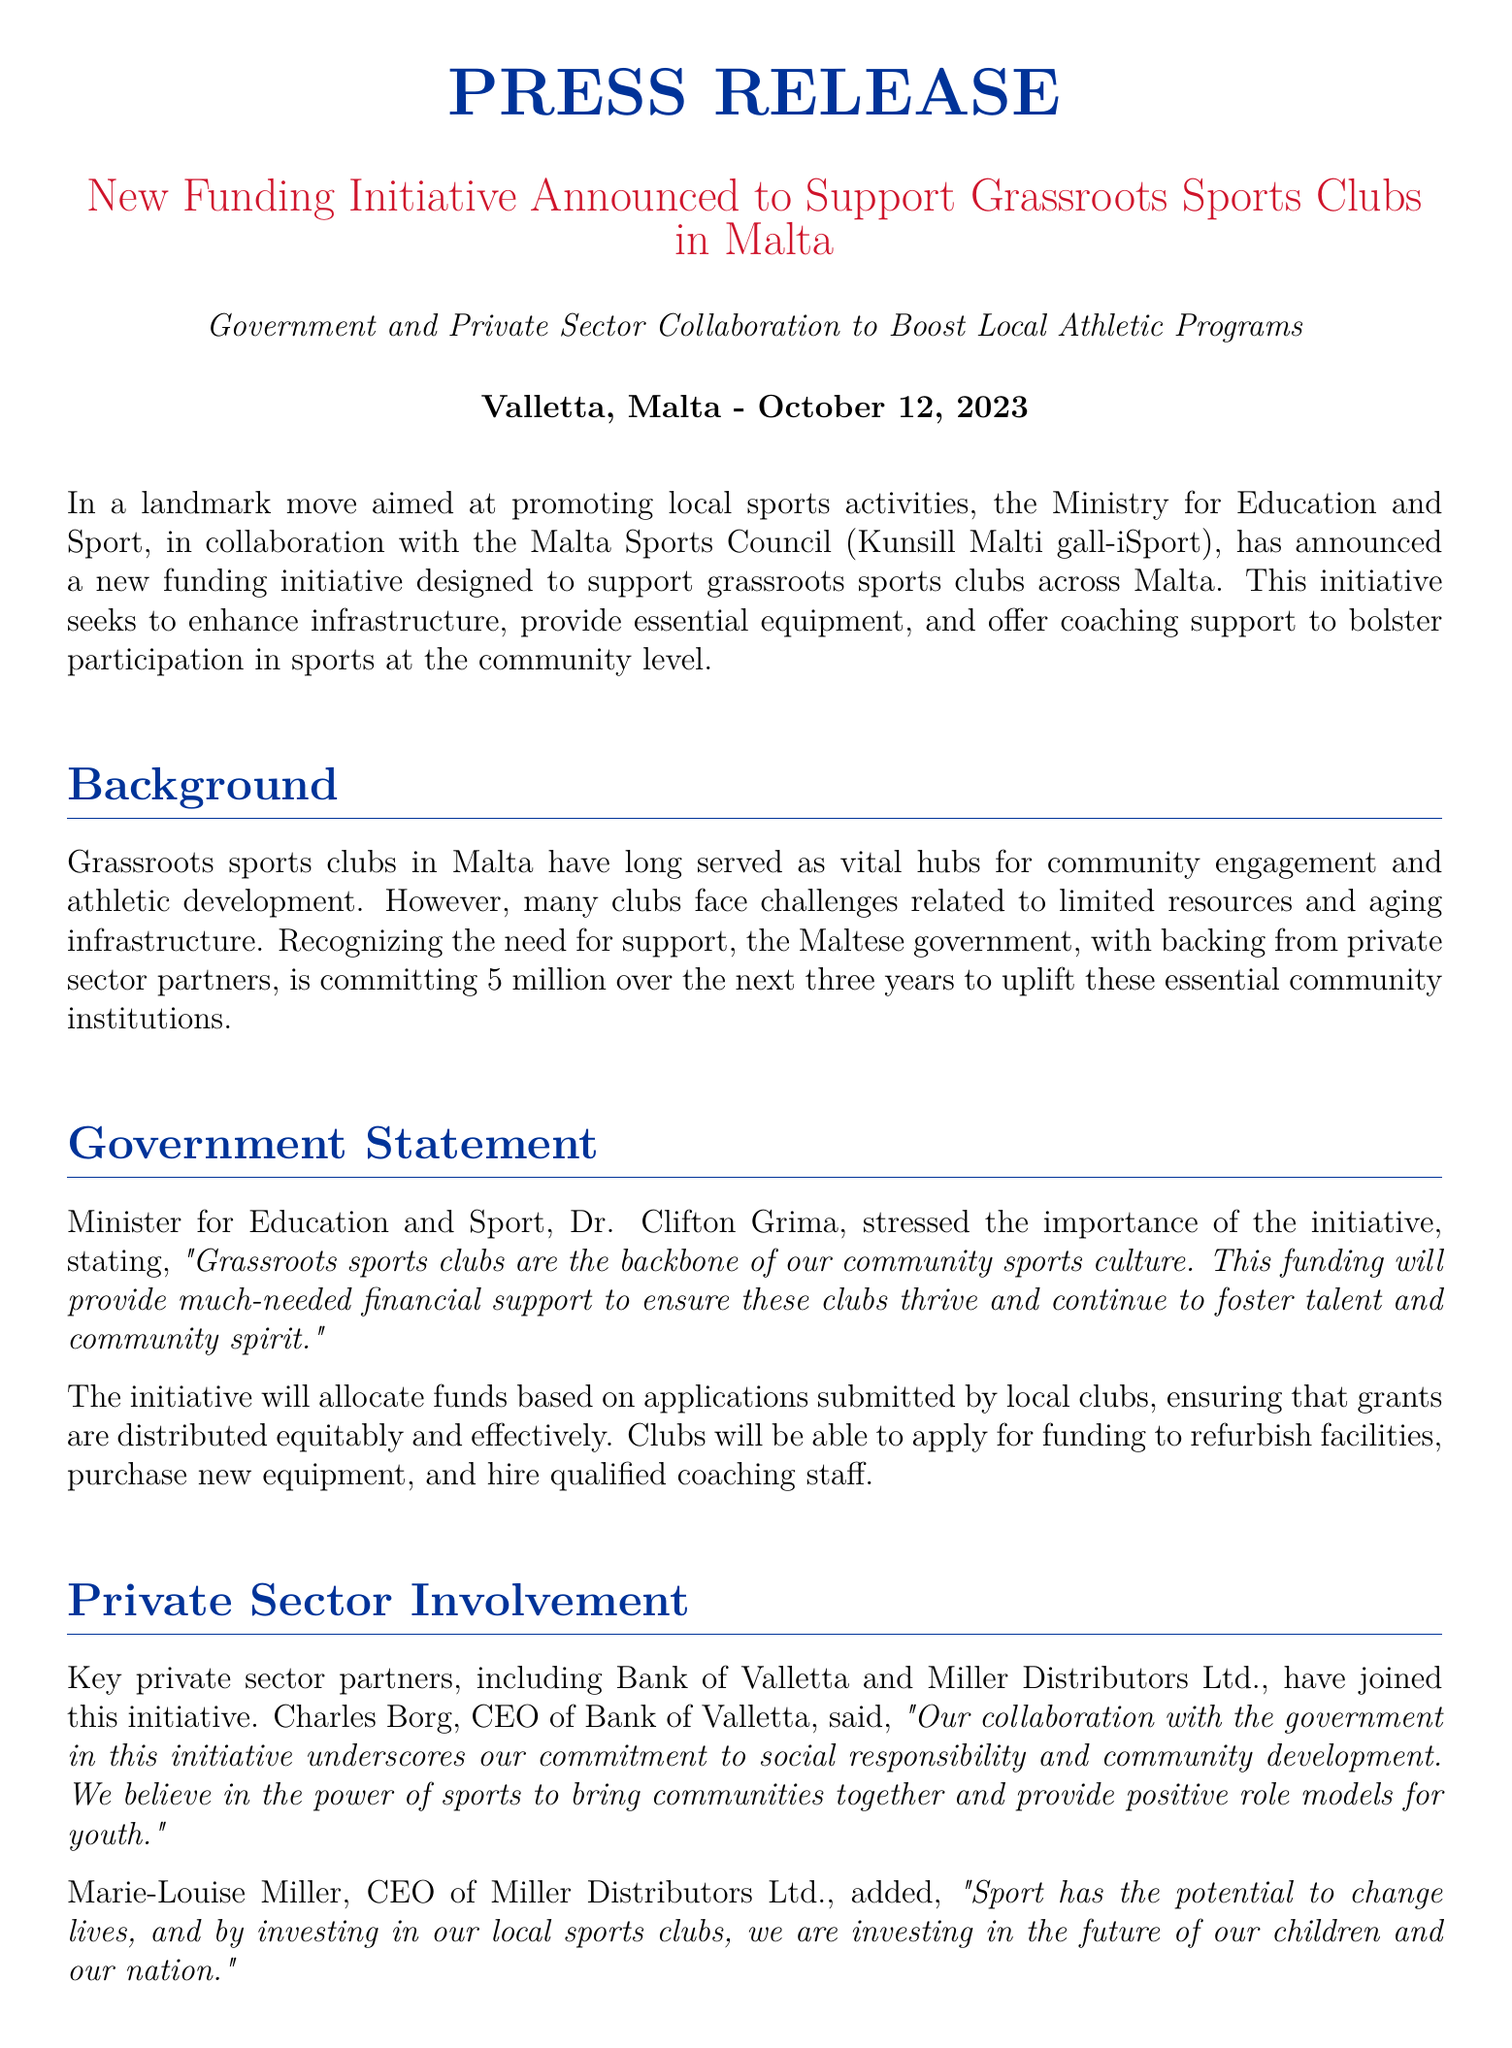What is the total funding amount for the initiative? The document states that the Maltese government is committing €5 million over the next three years to support grassroots sports clubs.
Answer: €5 million Who is the Minister for Education and Sport? The document mentions that Dr. Clifton Grima is the Minister for Education and Sport who made statements regarding the initiative.
Answer: Dr. Clifton Grima Which private sector partner is mentioned first in the document? The press release lists Bank of Valletta as the first private sector partner involved in the initiative.
Answer: Bank of Valletta What is the expected community impact of this funding initiative? The document outlines significant benefits such as enhanced physical and mental health and strengthened community bonds through shared sports experiences.
Answer: Enhanced physical and mental health Who commented on the funding as a game changer for clubs? The press release quotes John Camilleri, President of the Marsaxlokk Youth Football Club, regarding the impact of the funding on clubs.
Answer: John Camilleri What is the main purpose of this funding initiative? The document states that the main goal of the initiative is to support grassroots sports clubs by enhancing infrastructure, providing essential equipment, and offering coaching support.
Answer: Support grassroots sports clubs What type of collaboration is highlighted in this funding initiative? The document emphasizes a collaboration between the government and private sector to boost local athletic programs.
Answer: Government and Private Sector Collaboration How can clubs apply for the funding? The document mentions that clubs will be able to apply for funding through applications submitted to receive grants for refurbishing facilities and other needs.
Answer: By submitting applications 